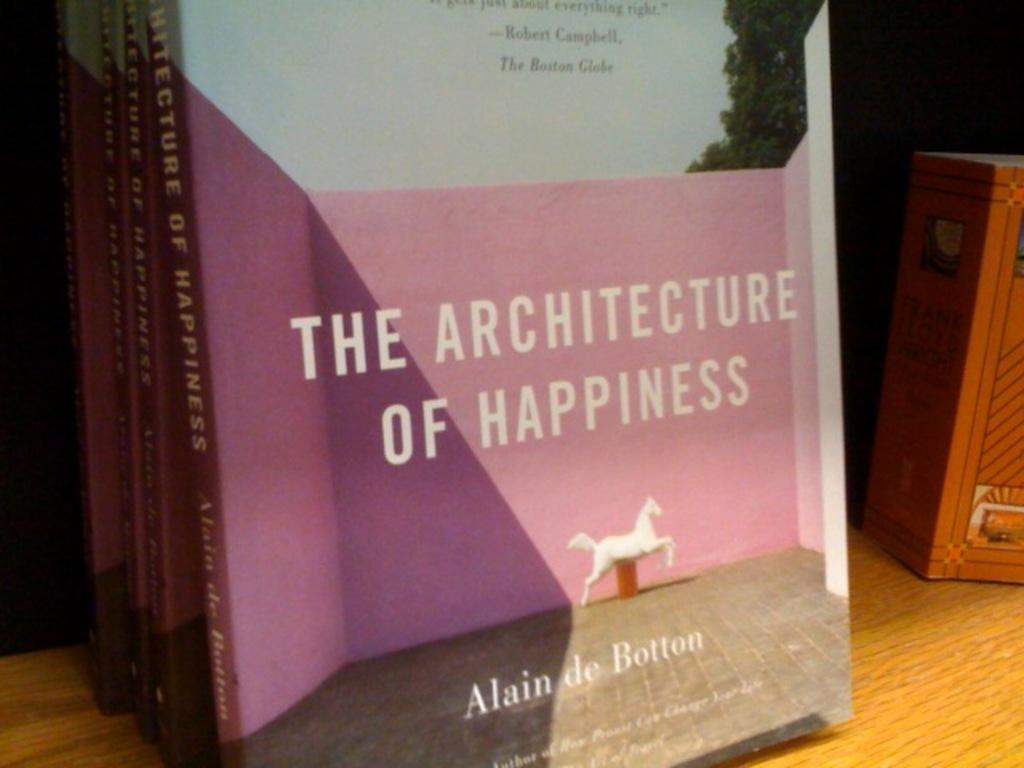<image>
Describe the image concisely. A stack of books titled "The Architecture of Happiness" leaning on a wall. 